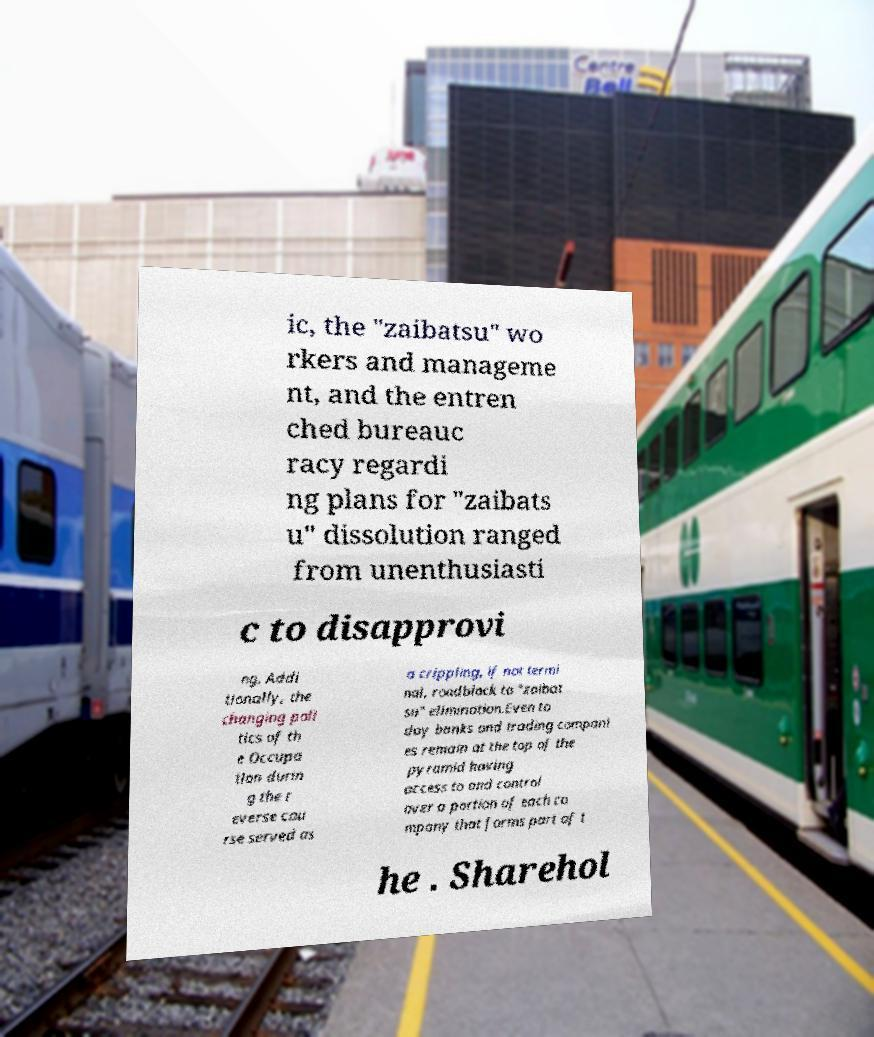Please identify and transcribe the text found in this image. ic, the "zaibatsu" wo rkers and manageme nt, and the entren ched bureauc racy regardi ng plans for "zaibats u" dissolution ranged from unenthusiasti c to disapprovi ng. Addi tionally, the changing poli tics of th e Occupa tion durin g the r everse cou rse served as a crippling, if not termi nal, roadblock to "zaibat su" elimination.Even to day banks and trading compani es remain at the top of the pyramid having access to and control over a portion of each co mpany that forms part of t he . Sharehol 